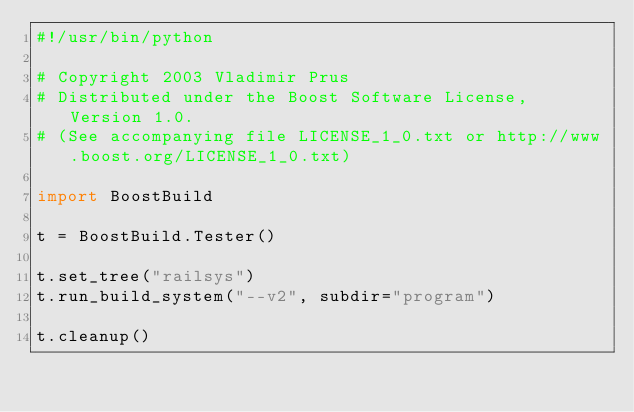<code> <loc_0><loc_0><loc_500><loc_500><_Python_>#!/usr/bin/python

# Copyright 2003 Vladimir Prus
# Distributed under the Boost Software License, Version 1.0.
# (See accompanying file LICENSE_1_0.txt or http://www.boost.org/LICENSE_1_0.txt)

import BoostBuild

t = BoostBuild.Tester()

t.set_tree("railsys")
t.run_build_system("--v2", subdir="program")

t.cleanup()
</code> 